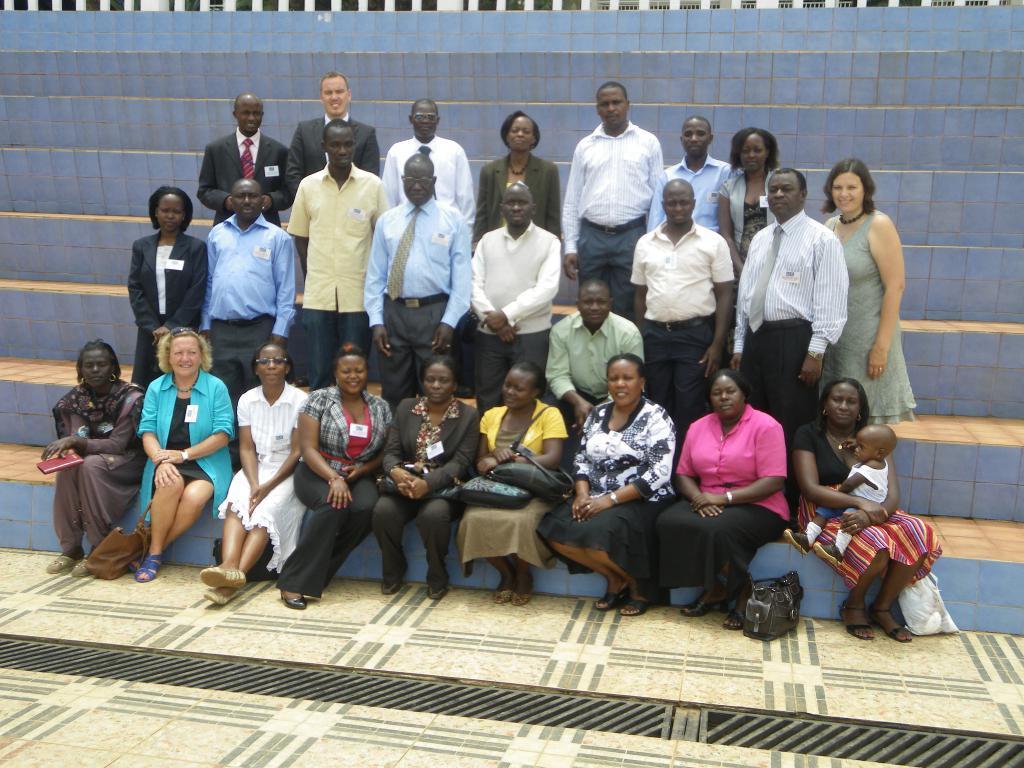Could you give a brief overview of what you see in this image? In this image we can see a few people, among them some people are sitting and some people are standing, in the background we can see the white color fence. 